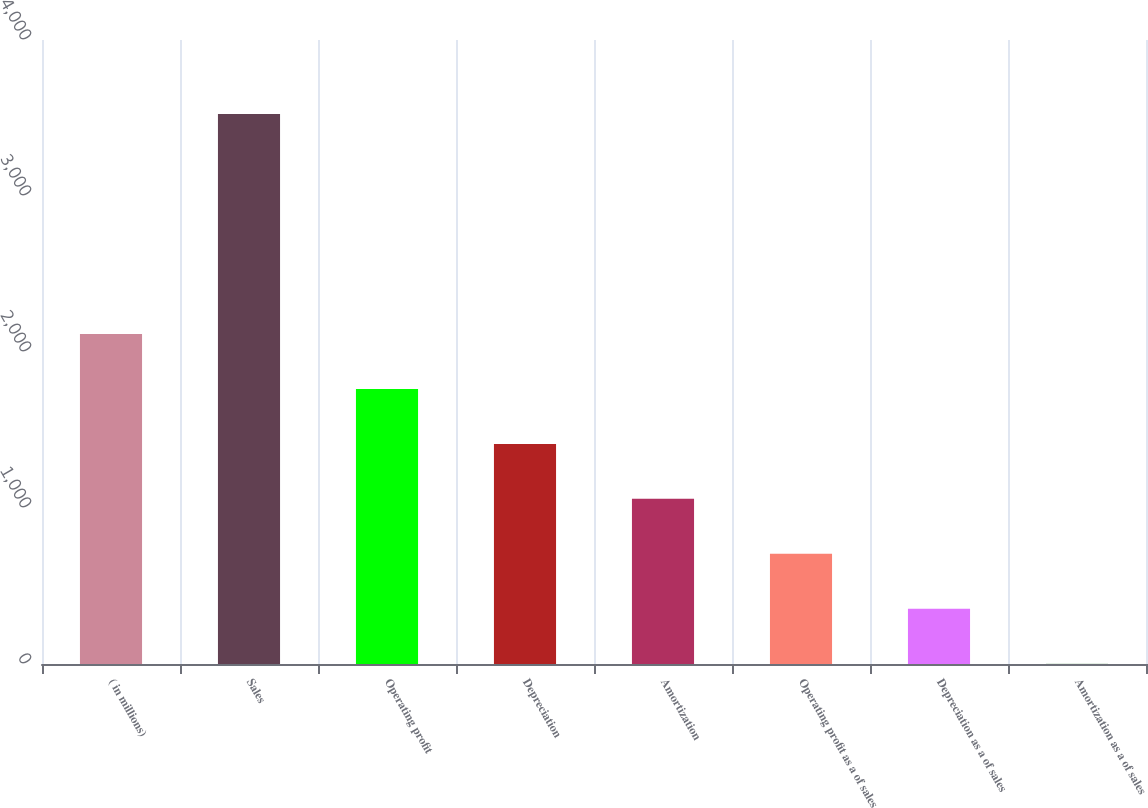<chart> <loc_0><loc_0><loc_500><loc_500><bar_chart><fcel>( in millions)<fcel>Sales<fcel>Operating profit<fcel>Depreciation<fcel>Amortization<fcel>Operating profit as a of sales<fcel>Depreciation as a of sales<fcel>Amortization as a of sales<nl><fcel>2115.96<fcel>3525.8<fcel>1763.5<fcel>1411.04<fcel>1058.58<fcel>706.12<fcel>353.66<fcel>1.2<nl></chart> 